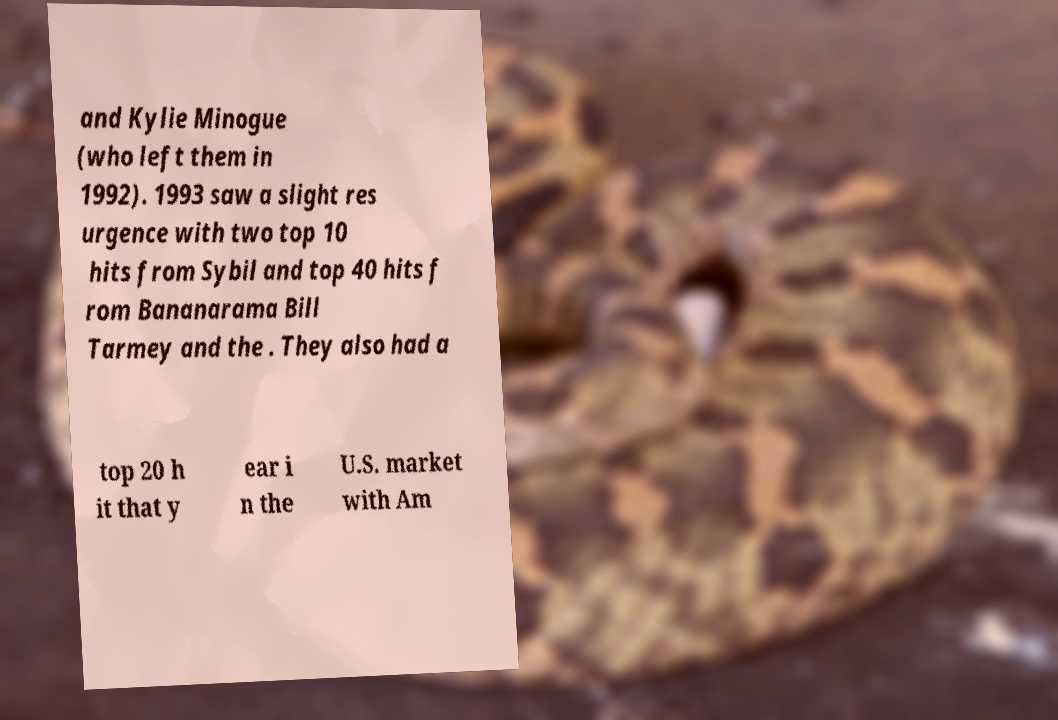Please identify and transcribe the text found in this image. and Kylie Minogue (who left them in 1992). 1993 saw a slight res urgence with two top 10 hits from Sybil and top 40 hits f rom Bananarama Bill Tarmey and the . They also had a top 20 h it that y ear i n the U.S. market with Am 